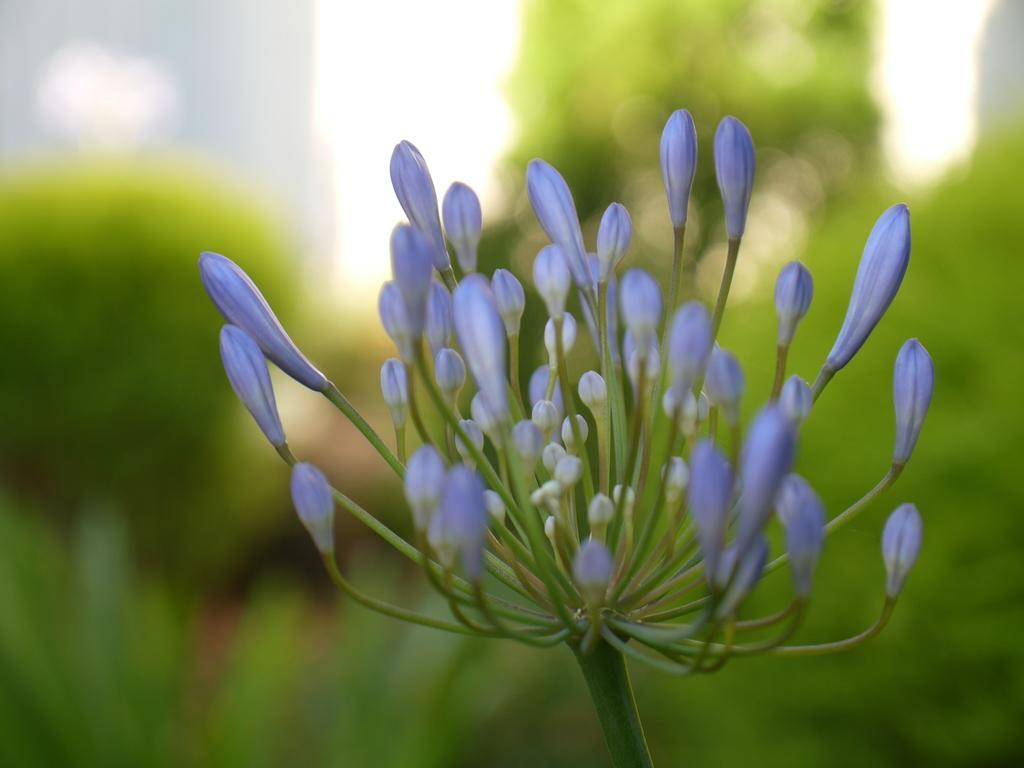Can you describe this image briefly? This image is taken outdoors. In the background there are a few trees and plants. In the middle of the image there is a plant with a few buds. 